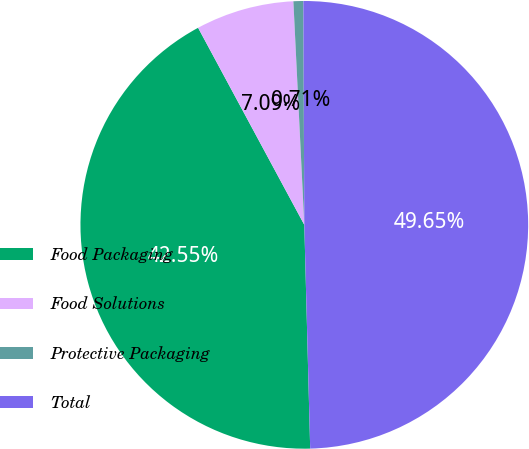Convert chart. <chart><loc_0><loc_0><loc_500><loc_500><pie_chart><fcel>Food Packaging<fcel>Food Solutions<fcel>Protective Packaging<fcel>Total<nl><fcel>42.55%<fcel>7.09%<fcel>0.71%<fcel>49.65%<nl></chart> 